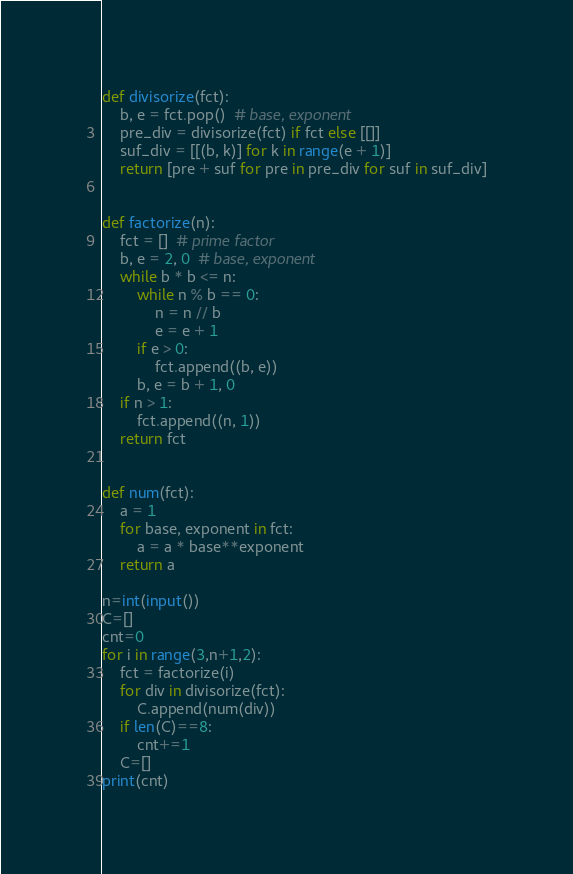<code> <loc_0><loc_0><loc_500><loc_500><_Python_>def divisorize(fct):
    b, e = fct.pop()  # base, exponent
    pre_div = divisorize(fct) if fct else [[]]
    suf_div = [[(b, k)] for k in range(e + 1)]
    return [pre + suf for pre in pre_div for suf in suf_div]


def factorize(n):
    fct = []  # prime factor
    b, e = 2, 0  # base, exponent
    while b * b <= n:
        while n % b == 0:
            n = n // b
            e = e + 1
        if e > 0:
            fct.append((b, e))
        b, e = b + 1, 0
    if n > 1:
        fct.append((n, 1))
    return fct


def num(fct):
    a = 1
    for base, exponent in fct:
        a = a * base**exponent
    return a

n=int(input())
C=[]
cnt=0
for i in range(3,n+1,2):
    fct = factorize(i)
    for div in divisorize(fct):
        C.append(num(div))
    if len(C)==8:
        cnt+=1
    C=[]
print(cnt)</code> 